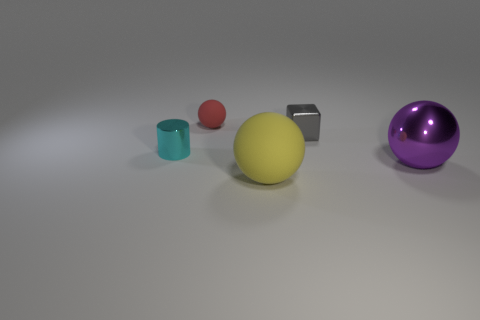Subtract all purple balls. Subtract all cyan cylinders. How many balls are left? 2 Add 2 large yellow matte cubes. How many objects exist? 7 Subtract all spheres. How many objects are left? 2 Add 2 large yellow matte things. How many large yellow matte things are left? 3 Add 1 tiny gray metallic cylinders. How many tiny gray metallic cylinders exist? 1 Subtract 1 purple balls. How many objects are left? 4 Subtract all large yellow cylinders. Subtract all purple shiny objects. How many objects are left? 4 